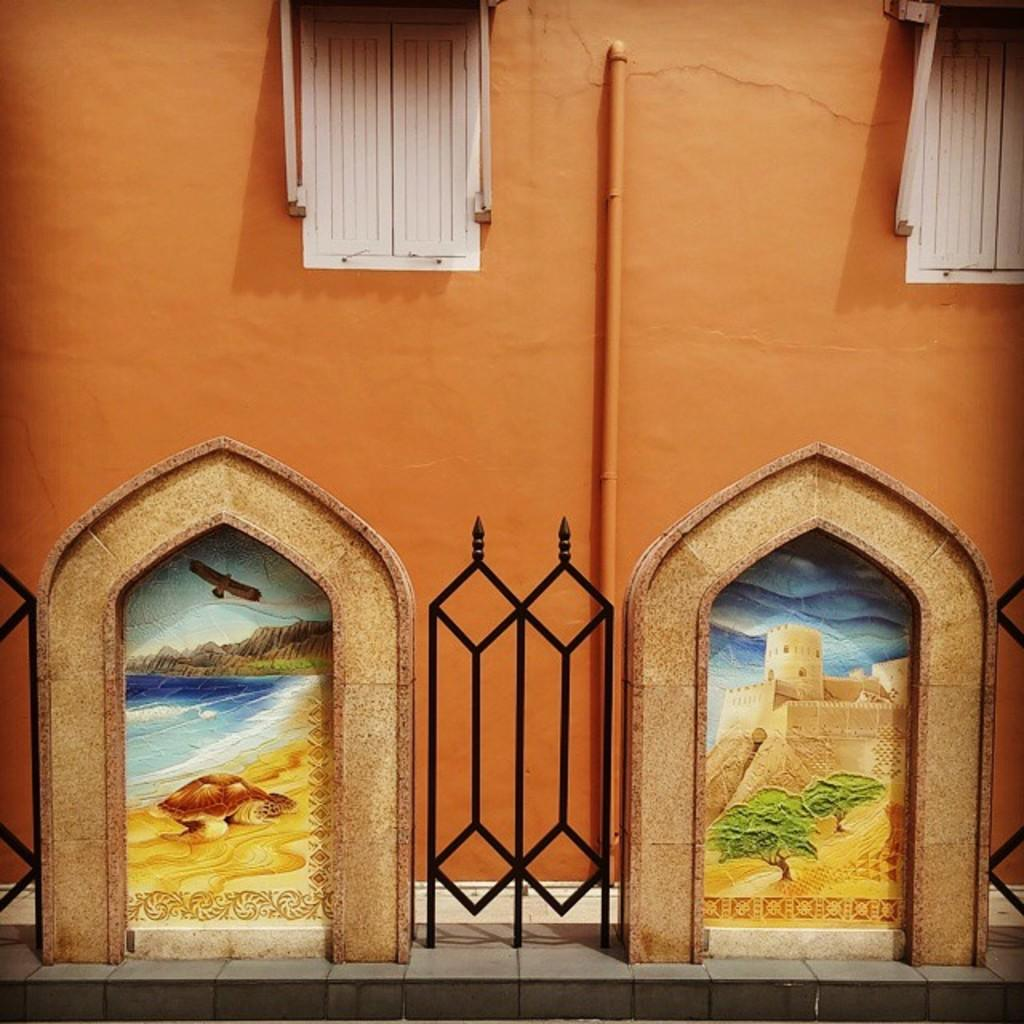What type of structure can be seen in the image? There is a railing in the image. What architectural feature is visible in the image? There are windows in the image. What type of object is present in the image? There is a pipe in the image. Where is the painting located in the image? The painting is on a wall in the image. How many hens are visible in the image? There are no hens present in the image. What type of stitch is used in the painting on the wall? There is no mention of a stitch in the image, as it features a painting on a wall but does not provide details about the painting's style or technique. 